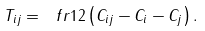Convert formula to latex. <formula><loc_0><loc_0><loc_500><loc_500>T _ { i j } = \ f r { 1 } { 2 } \left ( C _ { i j } - C _ { i } - C _ { j } \right ) .</formula> 